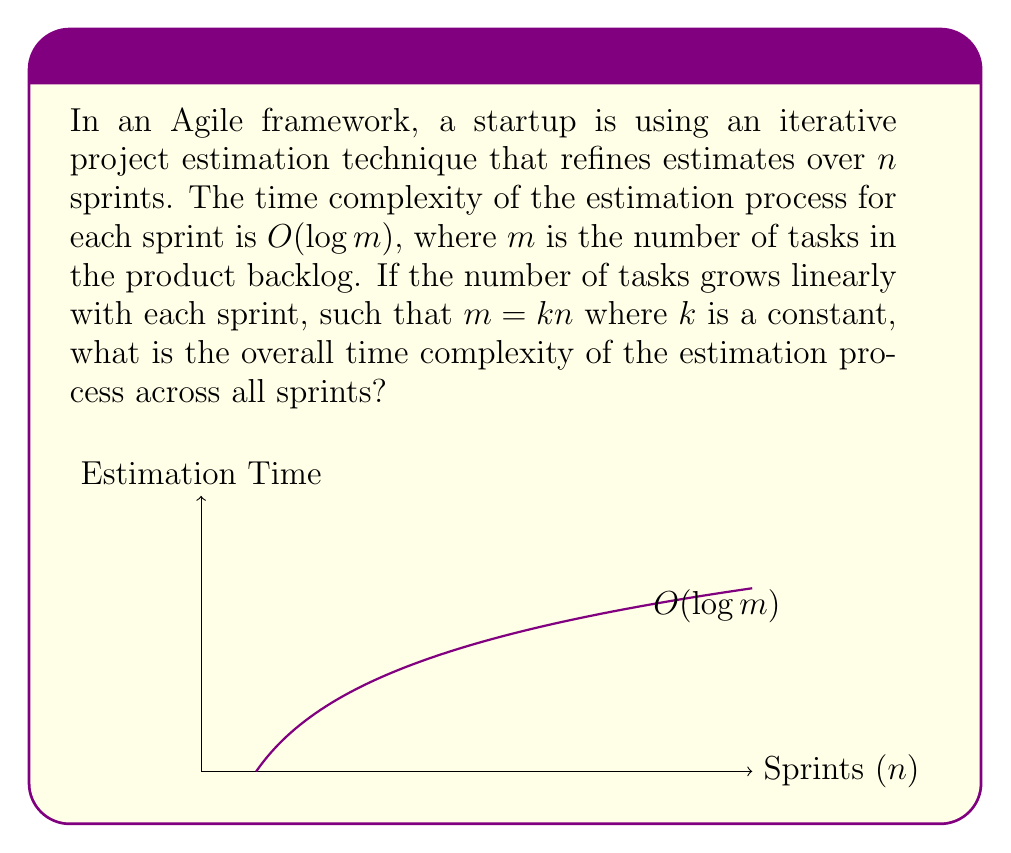Provide a solution to this math problem. Let's approach this step-by-step:

1) For each sprint, the estimation process has a time complexity of $O(\log m)$.

2) We're told that $m = kn$, where $n$ is the number of sprints and $k$ is a constant.

3) Substituting this into our complexity, we get $O(\log(kn))$ for each sprint.

4) Using the logarithm property $\log(ab) = \log(a) + \log(b)$, we can rewrite this as:
   $O(\log k + \log n)$

5) Since $k$ is a constant, $\log k$ is also a constant. In Big O notation, we can drop constants, so this simplifies to:
   $O(\log n)$ for each sprint

6) Now, we need to consider that this process happens for each of the $n$ sprints. When we have a process that repeats $n$ times, and each iteration takes $O(\log n)$ time, we multiply these together:
   $O(n \log n)$

7) This $O(n \log n)$ represents the overall time complexity across all sprints.

In the context of Agile project management, this result suggests that as the number of sprints (and consequently, the number of tasks) increases, the time required for estimation grows slightly faster than linear, but not as fast as quadratic. This insight can be valuable for planning and optimizing the estimation process in long-term Agile projects.
Answer: $O(n \log n)$ 